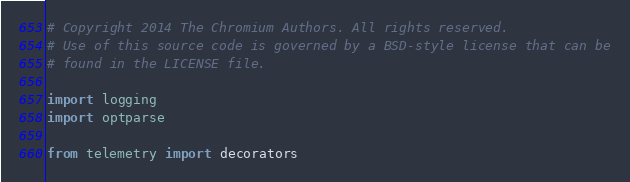<code> <loc_0><loc_0><loc_500><loc_500><_Python_># Copyright 2014 The Chromium Authors. All rights reserved.
# Use of this source code is governed by a BSD-style license that can be
# found in the LICENSE file.

import logging
import optparse

from telemetry import decorators</code> 